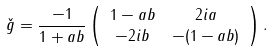<formula> <loc_0><loc_0><loc_500><loc_500>\check { g } & = \frac { - 1 } { 1 + a b } \left ( \begin{array} { c c } 1 - a b & 2 i a \\ - 2 i b & - ( 1 - a b ) \end{array} \right ) .</formula> 